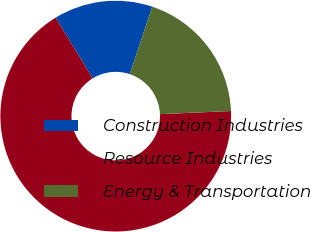Convert chart to OTSL. <chart><loc_0><loc_0><loc_500><loc_500><pie_chart><fcel>Construction Industries<fcel>Resource Industries<fcel>Energy & Transportation<nl><fcel>13.86%<fcel>66.97%<fcel>19.17%<nl></chart> 